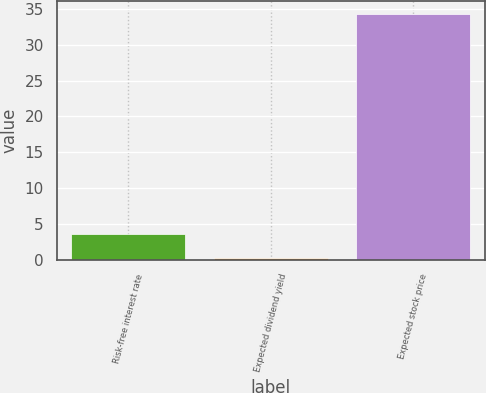Convert chart to OTSL. <chart><loc_0><loc_0><loc_500><loc_500><bar_chart><fcel>Risk-free interest rate<fcel>Expected dividend yield<fcel>Expected stock price<nl><fcel>3.6<fcel>0.19<fcel>34.3<nl></chart> 